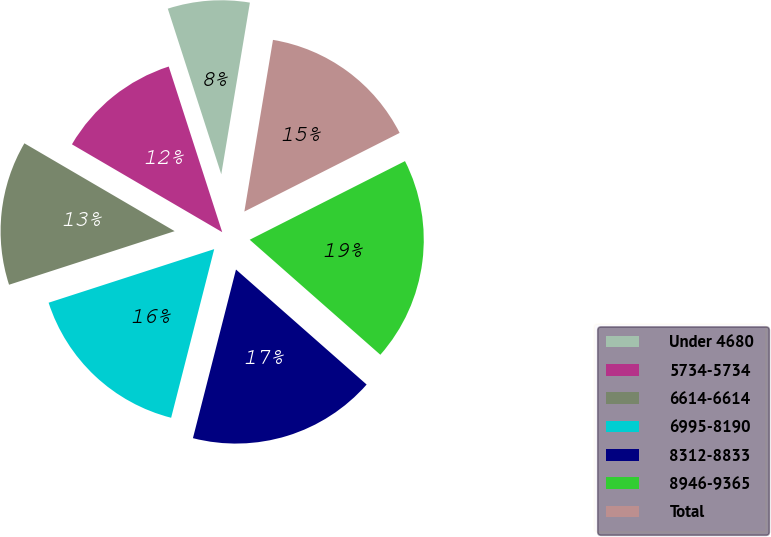Convert chart to OTSL. <chart><loc_0><loc_0><loc_500><loc_500><pie_chart><fcel>Under 4680<fcel>5734-5734<fcel>6614-6614<fcel>6995-8190<fcel>8312-8833<fcel>8946-9365<fcel>Total<nl><fcel>7.6%<fcel>11.61%<fcel>13.4%<fcel>16.04%<fcel>17.49%<fcel>18.95%<fcel>14.91%<nl></chart> 